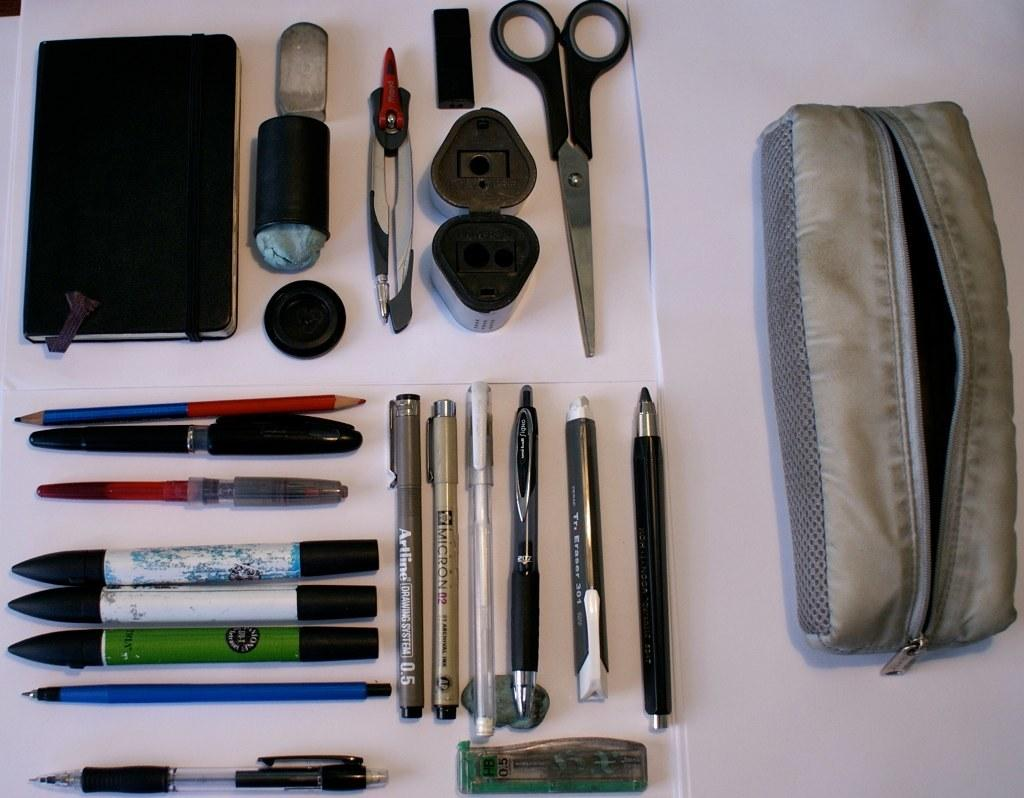What types of writing instruments are visible in the image? There are pens, markers, and a pencil in the image. What other stationery items can be seen in the image? There are scissors and a stamp pad in the image. Where are these objects located? The objects are on a table in the image. Is there any storage item for these stationery items? Yes, there is a pouch in the image. How much does the summer season weigh in the image? There is no reference to the summer season or any weights in the image, so it is not possible to answer that question. 